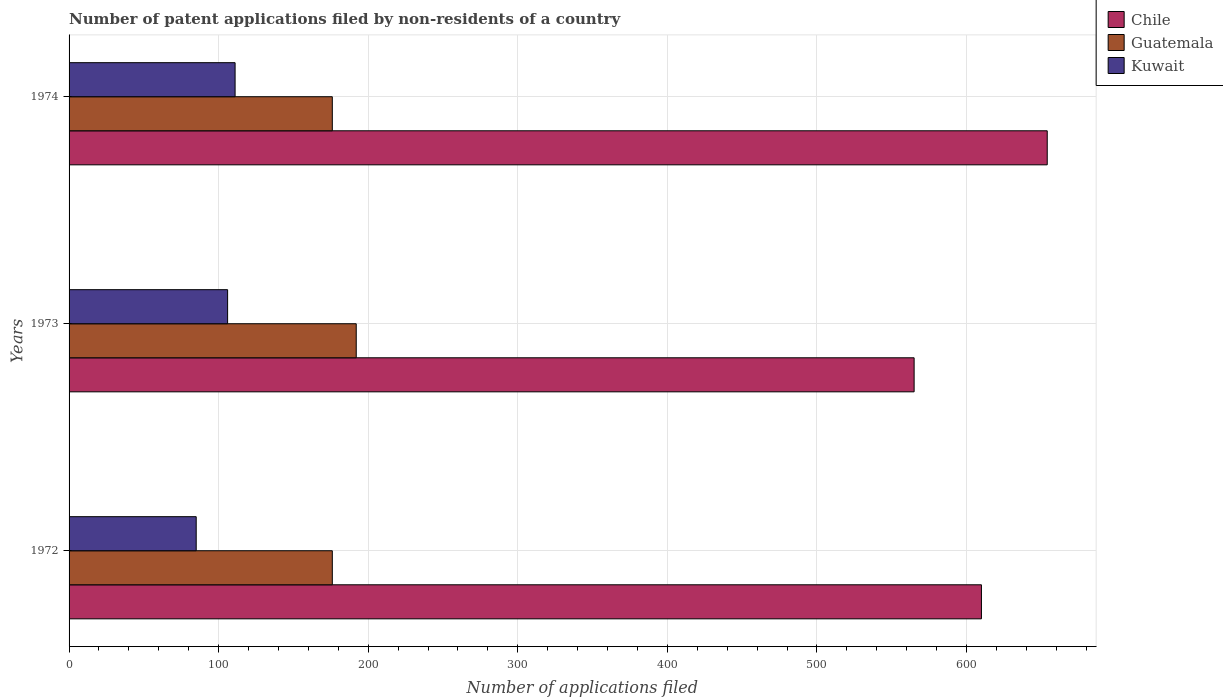How many bars are there on the 1st tick from the top?
Ensure brevity in your answer.  3. How many bars are there on the 3rd tick from the bottom?
Provide a short and direct response. 3. What is the label of the 2nd group of bars from the top?
Make the answer very short. 1973. What is the number of applications filed in Guatemala in 1973?
Offer a terse response. 192. Across all years, what is the maximum number of applications filed in Chile?
Provide a short and direct response. 654. In which year was the number of applications filed in Chile maximum?
Ensure brevity in your answer.  1974. In which year was the number of applications filed in Kuwait minimum?
Keep it short and to the point. 1972. What is the total number of applications filed in Chile in the graph?
Keep it short and to the point. 1829. What is the difference between the number of applications filed in Guatemala in 1972 and the number of applications filed in Chile in 1974?
Your answer should be compact. -478. What is the average number of applications filed in Kuwait per year?
Your answer should be compact. 100.67. In the year 1972, what is the difference between the number of applications filed in Chile and number of applications filed in Guatemala?
Give a very brief answer. 434. What is the ratio of the number of applications filed in Chile in 1973 to that in 1974?
Offer a terse response. 0.86. Is the difference between the number of applications filed in Chile in 1973 and 1974 greater than the difference between the number of applications filed in Guatemala in 1973 and 1974?
Provide a succinct answer. No. In how many years, is the number of applications filed in Kuwait greater than the average number of applications filed in Kuwait taken over all years?
Keep it short and to the point. 2. Is the sum of the number of applications filed in Kuwait in 1972 and 1973 greater than the maximum number of applications filed in Guatemala across all years?
Give a very brief answer. No. What does the 1st bar from the top in 1972 represents?
Offer a very short reply. Kuwait. What does the 2nd bar from the bottom in 1974 represents?
Give a very brief answer. Guatemala. How many years are there in the graph?
Your answer should be compact. 3. What is the difference between two consecutive major ticks on the X-axis?
Provide a short and direct response. 100. Does the graph contain any zero values?
Offer a very short reply. No. Where does the legend appear in the graph?
Offer a terse response. Top right. How many legend labels are there?
Ensure brevity in your answer.  3. What is the title of the graph?
Keep it short and to the point. Number of patent applications filed by non-residents of a country. What is the label or title of the X-axis?
Your answer should be very brief. Number of applications filed. What is the Number of applications filed of Chile in 1972?
Keep it short and to the point. 610. What is the Number of applications filed in Guatemala in 1972?
Keep it short and to the point. 176. What is the Number of applications filed of Chile in 1973?
Your response must be concise. 565. What is the Number of applications filed in Guatemala in 1973?
Offer a very short reply. 192. What is the Number of applications filed of Kuwait in 1973?
Ensure brevity in your answer.  106. What is the Number of applications filed in Chile in 1974?
Give a very brief answer. 654. What is the Number of applications filed in Guatemala in 1974?
Make the answer very short. 176. What is the Number of applications filed of Kuwait in 1974?
Your response must be concise. 111. Across all years, what is the maximum Number of applications filed of Chile?
Ensure brevity in your answer.  654. Across all years, what is the maximum Number of applications filed in Guatemala?
Ensure brevity in your answer.  192. Across all years, what is the maximum Number of applications filed in Kuwait?
Give a very brief answer. 111. Across all years, what is the minimum Number of applications filed of Chile?
Your response must be concise. 565. Across all years, what is the minimum Number of applications filed of Guatemala?
Your response must be concise. 176. Across all years, what is the minimum Number of applications filed of Kuwait?
Keep it short and to the point. 85. What is the total Number of applications filed in Chile in the graph?
Keep it short and to the point. 1829. What is the total Number of applications filed in Guatemala in the graph?
Make the answer very short. 544. What is the total Number of applications filed in Kuwait in the graph?
Provide a succinct answer. 302. What is the difference between the Number of applications filed of Chile in 1972 and that in 1973?
Make the answer very short. 45. What is the difference between the Number of applications filed in Guatemala in 1972 and that in 1973?
Your response must be concise. -16. What is the difference between the Number of applications filed of Chile in 1972 and that in 1974?
Your answer should be very brief. -44. What is the difference between the Number of applications filed of Kuwait in 1972 and that in 1974?
Make the answer very short. -26. What is the difference between the Number of applications filed in Chile in 1973 and that in 1974?
Make the answer very short. -89. What is the difference between the Number of applications filed in Kuwait in 1973 and that in 1974?
Provide a succinct answer. -5. What is the difference between the Number of applications filed of Chile in 1972 and the Number of applications filed of Guatemala in 1973?
Provide a succinct answer. 418. What is the difference between the Number of applications filed of Chile in 1972 and the Number of applications filed of Kuwait in 1973?
Provide a short and direct response. 504. What is the difference between the Number of applications filed in Chile in 1972 and the Number of applications filed in Guatemala in 1974?
Give a very brief answer. 434. What is the difference between the Number of applications filed of Chile in 1972 and the Number of applications filed of Kuwait in 1974?
Your response must be concise. 499. What is the difference between the Number of applications filed in Guatemala in 1972 and the Number of applications filed in Kuwait in 1974?
Offer a terse response. 65. What is the difference between the Number of applications filed of Chile in 1973 and the Number of applications filed of Guatemala in 1974?
Offer a terse response. 389. What is the difference between the Number of applications filed in Chile in 1973 and the Number of applications filed in Kuwait in 1974?
Your response must be concise. 454. What is the difference between the Number of applications filed of Guatemala in 1973 and the Number of applications filed of Kuwait in 1974?
Offer a terse response. 81. What is the average Number of applications filed of Chile per year?
Provide a succinct answer. 609.67. What is the average Number of applications filed in Guatemala per year?
Give a very brief answer. 181.33. What is the average Number of applications filed of Kuwait per year?
Provide a succinct answer. 100.67. In the year 1972, what is the difference between the Number of applications filed of Chile and Number of applications filed of Guatemala?
Offer a terse response. 434. In the year 1972, what is the difference between the Number of applications filed of Chile and Number of applications filed of Kuwait?
Ensure brevity in your answer.  525. In the year 1972, what is the difference between the Number of applications filed of Guatemala and Number of applications filed of Kuwait?
Keep it short and to the point. 91. In the year 1973, what is the difference between the Number of applications filed in Chile and Number of applications filed in Guatemala?
Your answer should be very brief. 373. In the year 1973, what is the difference between the Number of applications filed in Chile and Number of applications filed in Kuwait?
Your response must be concise. 459. In the year 1973, what is the difference between the Number of applications filed of Guatemala and Number of applications filed of Kuwait?
Your answer should be compact. 86. In the year 1974, what is the difference between the Number of applications filed in Chile and Number of applications filed in Guatemala?
Your answer should be compact. 478. In the year 1974, what is the difference between the Number of applications filed of Chile and Number of applications filed of Kuwait?
Keep it short and to the point. 543. What is the ratio of the Number of applications filed of Chile in 1972 to that in 1973?
Make the answer very short. 1.08. What is the ratio of the Number of applications filed in Kuwait in 1972 to that in 1973?
Keep it short and to the point. 0.8. What is the ratio of the Number of applications filed in Chile in 1972 to that in 1974?
Your answer should be compact. 0.93. What is the ratio of the Number of applications filed in Kuwait in 1972 to that in 1974?
Make the answer very short. 0.77. What is the ratio of the Number of applications filed in Chile in 1973 to that in 1974?
Ensure brevity in your answer.  0.86. What is the ratio of the Number of applications filed of Kuwait in 1973 to that in 1974?
Offer a very short reply. 0.95. What is the difference between the highest and the second highest Number of applications filed in Chile?
Offer a terse response. 44. What is the difference between the highest and the second highest Number of applications filed in Kuwait?
Your answer should be compact. 5. What is the difference between the highest and the lowest Number of applications filed in Chile?
Your response must be concise. 89. What is the difference between the highest and the lowest Number of applications filed of Guatemala?
Provide a succinct answer. 16. What is the difference between the highest and the lowest Number of applications filed of Kuwait?
Provide a succinct answer. 26. 